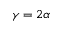<formula> <loc_0><loc_0><loc_500><loc_500>\gamma = 2 \alpha</formula> 